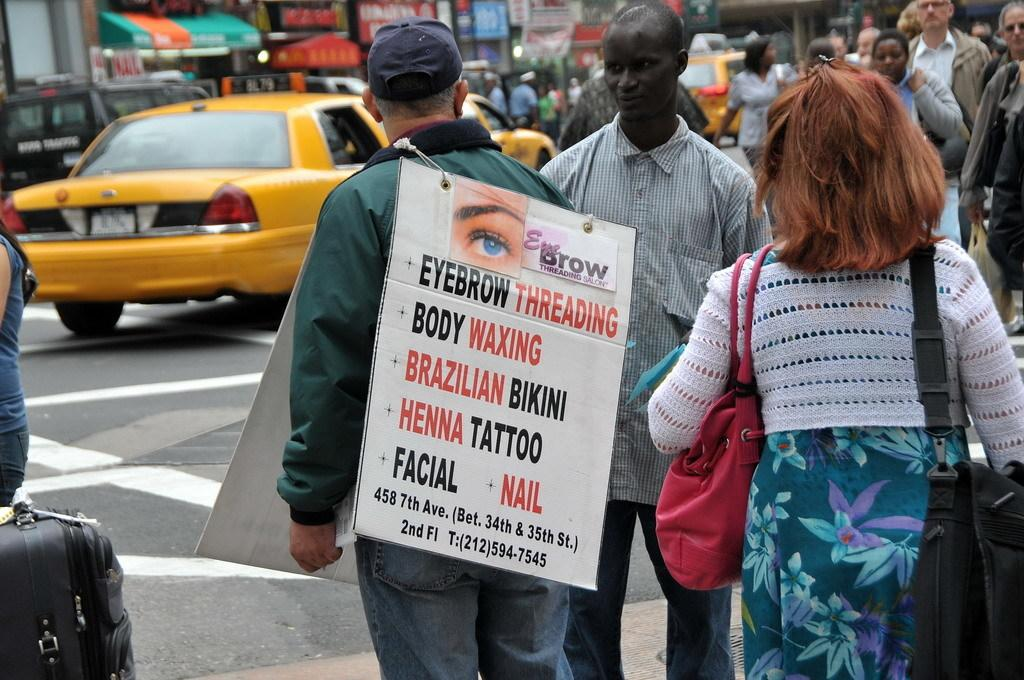<image>
Describe the image concisely. A man is on the street with a board advertising services such as eyebrow threading and henna tattoos. 